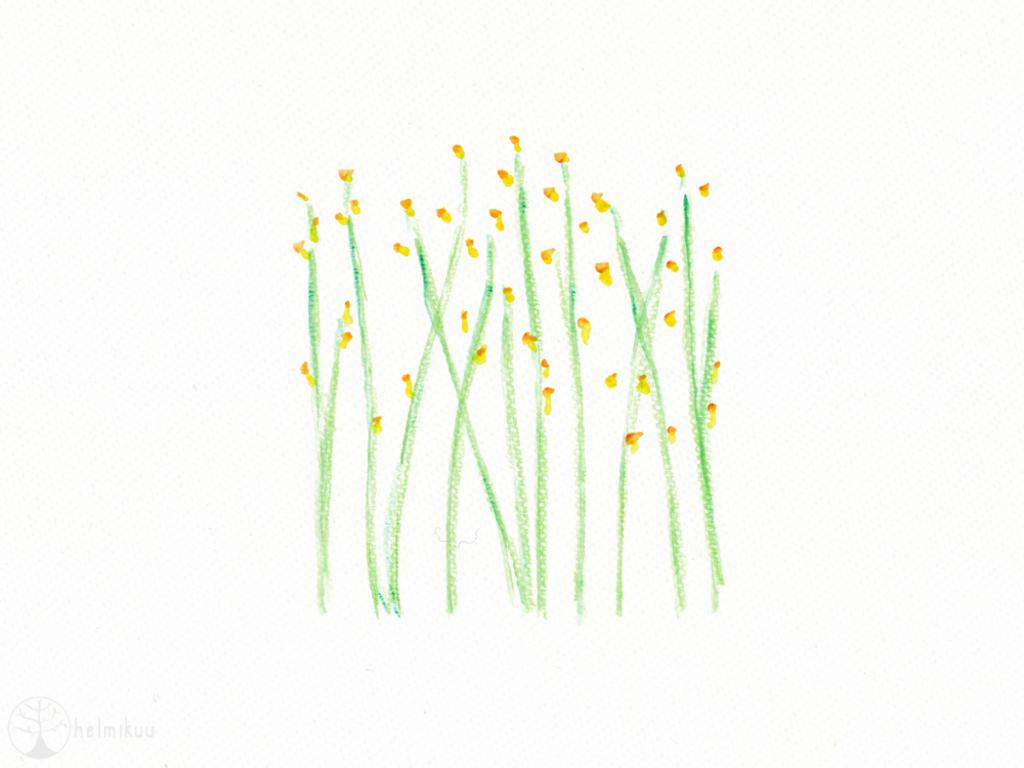What type of image is being described? The image is a drawing. What elements are included in the drawing? There are plants and flowers in the drawing. What is the purpose of the father in the drawing? There is no father present in the drawing; it only includes plants and flowers. 